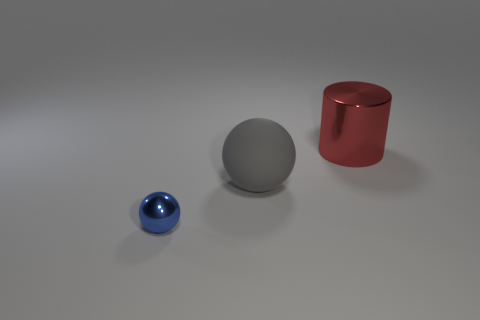What is the relative size of the blue ball compared to the red cylinder? The blue ball is significantly smaller in size when compared to the red cylinder. The cylinder is both taller and wider than the blue ball, conveying a clear contrast in their dimensions. 